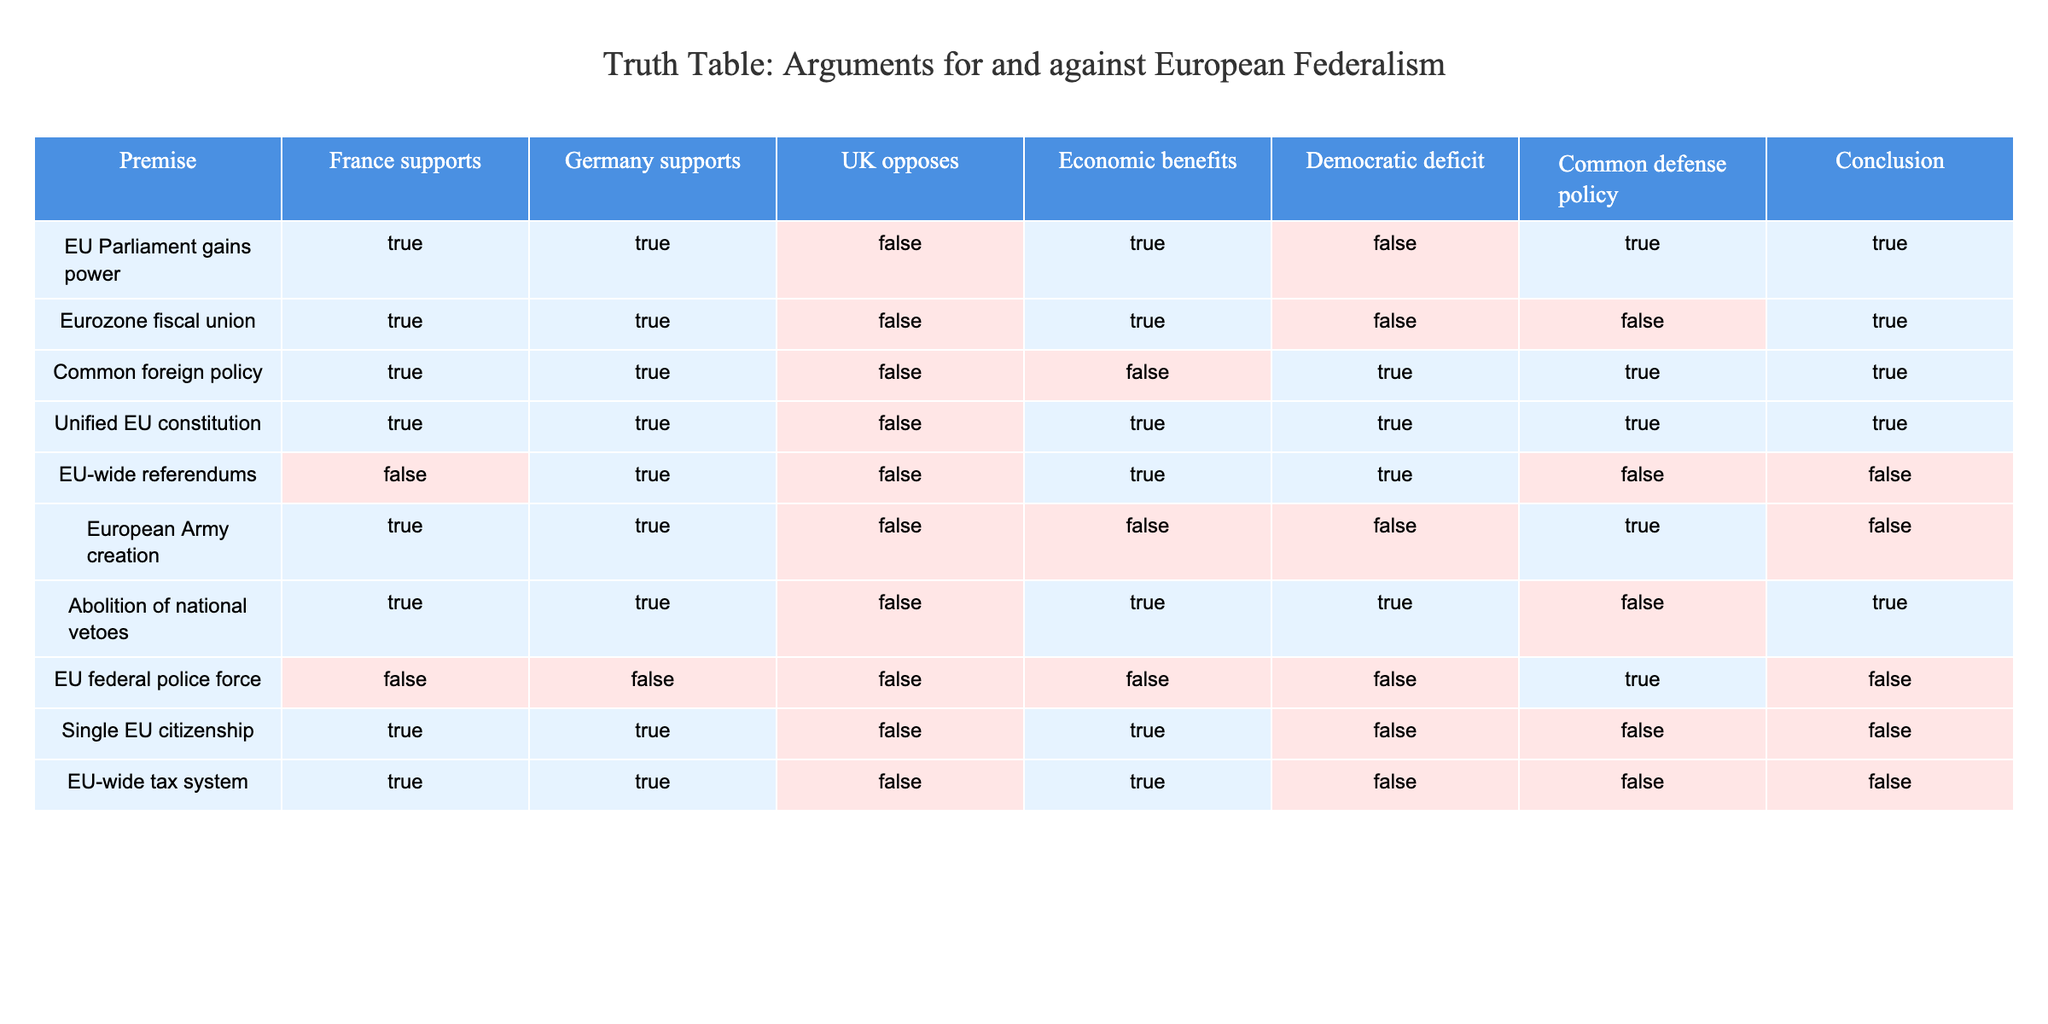What are the conclusions reached when "EU Parliament gains power"? In the row for "EU Parliament gains power", the conclusion is TRUE, indicating that this scenario advocates in favor of federalism. This is supported by the economic benefits and the common defense policy also being TRUE.
Answer: TRUE Which argument has the least support in favor of European federalism based on “EU-wide referendums”? The row for "EU-wide referendums" shows that both France (FALSE) and the UK (FALSE) oppose it, with a conclusion of FALSE. This indicates it has the least support for federalism.
Answer: FALSE How many arguments support a common defense policy while also being supported by both France and Germany? The rows to consider are "EU Parliament gains power", "Common foreign policy", "European Army creation", and "Abolition of national vetoes". "Common foreign policy" provides one argument not supporting it, revealing 3 arguments are in favor of the common defense policy (the first three rows).
Answer: 3 Do most of the arguments support or oppose the creation of a unified EU constitution? For "Unified EU constitution", both France and Germany support it, while the UK opposes it. The conclusion is TRUE, indicating overall support for this idea, despite the opposition from one member state.
Answer: Support Which argument results in a conclusion of FALSE due to lack of support for economic benefits? Observing the row "EU-wide tax system", it is supported by France and Germany, but since it generates no economic benefits, the conclusion is FALSE according to the data.
Answer: FALSE What is the only argument entirely opposed by all major countries? In the row for "EU federal police force", all three key countries (France, Germany, and the UK) have FALSE values leading to a FALSE conclusion about this argument being supported.
Answer: EU federal police force Which arguments have both Germany's support and a conclusion of TRUE? The arguments are "EU Parliament gains power", "Eurozone fiscal union", "Common foreign policy", "Unified EU constitution", and "Abolition of national vetoes". Thus, there are five arguments where Germany supports and the conclusion ends up being TRUE.
Answer: 5 Are there any arguments that both support and oppose economic benefits? The arguments are "EU Parliament gains power", "Eurozone fiscal union", and "Abolition of national vetoes" which supports economic benefits, contrasting with "EU federal police force" which does not. However, all are true in their regards.
Answer: Yes 